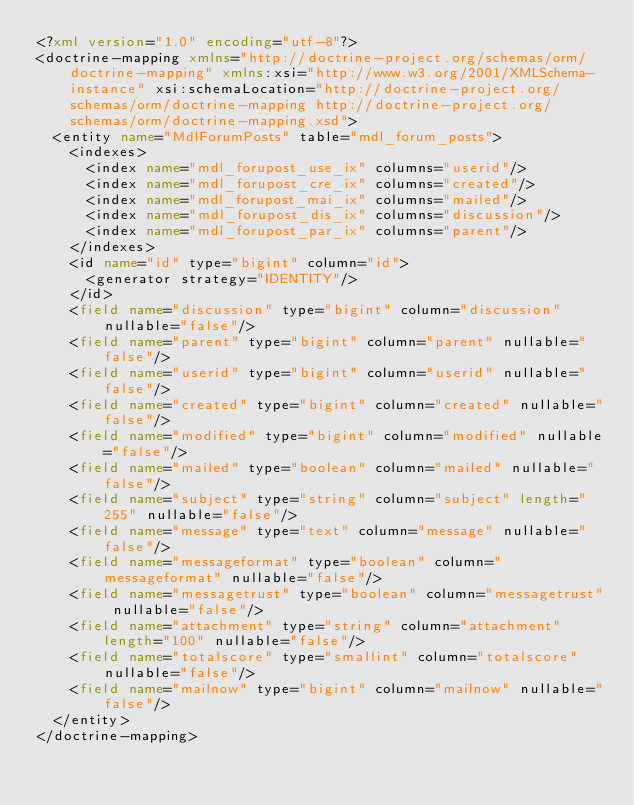<code> <loc_0><loc_0><loc_500><loc_500><_XML_><?xml version="1.0" encoding="utf-8"?>
<doctrine-mapping xmlns="http://doctrine-project.org/schemas/orm/doctrine-mapping" xmlns:xsi="http://www.w3.org/2001/XMLSchema-instance" xsi:schemaLocation="http://doctrine-project.org/schemas/orm/doctrine-mapping http://doctrine-project.org/schemas/orm/doctrine-mapping.xsd">
  <entity name="MdlForumPosts" table="mdl_forum_posts">
    <indexes>
      <index name="mdl_forupost_use_ix" columns="userid"/>
      <index name="mdl_forupost_cre_ix" columns="created"/>
      <index name="mdl_forupost_mai_ix" columns="mailed"/>
      <index name="mdl_forupost_dis_ix" columns="discussion"/>
      <index name="mdl_forupost_par_ix" columns="parent"/>
    </indexes>
    <id name="id" type="bigint" column="id">
      <generator strategy="IDENTITY"/>
    </id>
    <field name="discussion" type="bigint" column="discussion" nullable="false"/>
    <field name="parent" type="bigint" column="parent" nullable="false"/>
    <field name="userid" type="bigint" column="userid" nullable="false"/>
    <field name="created" type="bigint" column="created" nullable="false"/>
    <field name="modified" type="bigint" column="modified" nullable="false"/>
    <field name="mailed" type="boolean" column="mailed" nullable="false"/>
    <field name="subject" type="string" column="subject" length="255" nullable="false"/>
    <field name="message" type="text" column="message" nullable="false"/>
    <field name="messageformat" type="boolean" column="messageformat" nullable="false"/>
    <field name="messagetrust" type="boolean" column="messagetrust" nullable="false"/>
    <field name="attachment" type="string" column="attachment" length="100" nullable="false"/>
    <field name="totalscore" type="smallint" column="totalscore" nullable="false"/>
    <field name="mailnow" type="bigint" column="mailnow" nullable="false"/>
  </entity>
</doctrine-mapping>
</code> 